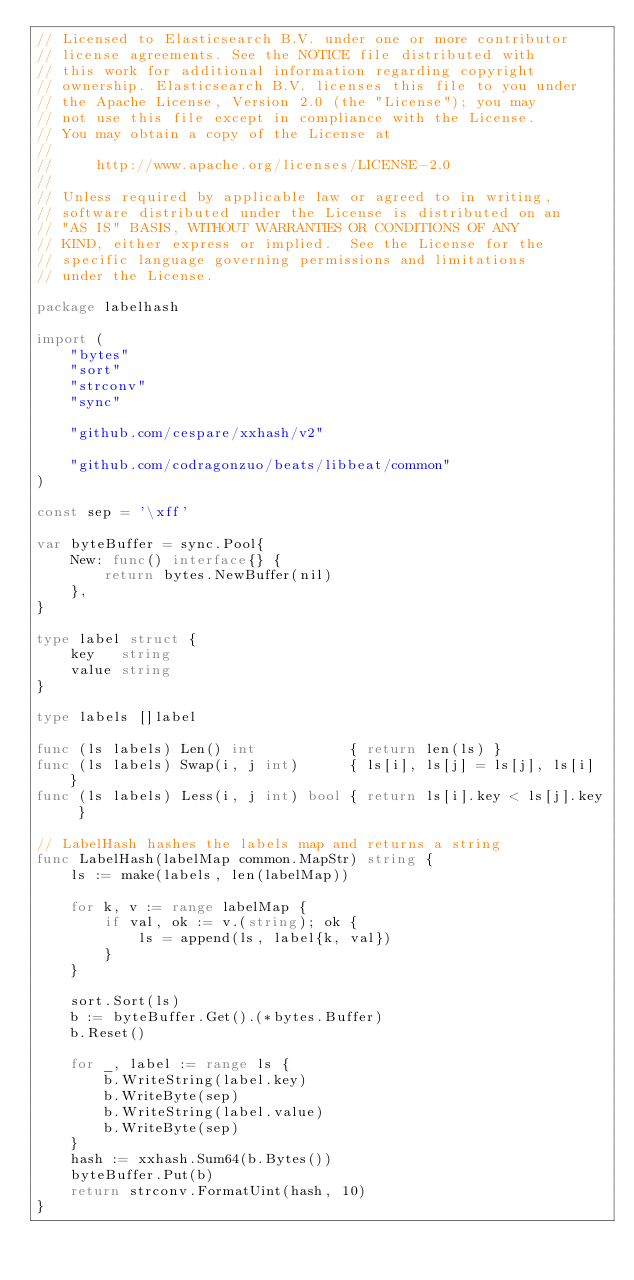<code> <loc_0><loc_0><loc_500><loc_500><_Go_>// Licensed to Elasticsearch B.V. under one or more contributor
// license agreements. See the NOTICE file distributed with
// this work for additional information regarding copyright
// ownership. Elasticsearch B.V. licenses this file to you under
// the Apache License, Version 2.0 (the "License"); you may
// not use this file except in compliance with the License.
// You may obtain a copy of the License at
//
//     http://www.apache.org/licenses/LICENSE-2.0
//
// Unless required by applicable law or agreed to in writing,
// software distributed under the License is distributed on an
// "AS IS" BASIS, WITHOUT WARRANTIES OR CONDITIONS OF ANY
// KIND, either express or implied.  See the License for the
// specific language governing permissions and limitations
// under the License.

package labelhash

import (
	"bytes"
	"sort"
	"strconv"
	"sync"

	"github.com/cespare/xxhash/v2"

	"github.com/codragonzuo/beats/libbeat/common"
)

const sep = '\xff'

var byteBuffer = sync.Pool{
	New: func() interface{} {
		return bytes.NewBuffer(nil)
	},
}

type label struct {
	key   string
	value string
}

type labels []label

func (ls labels) Len() int           { return len(ls) }
func (ls labels) Swap(i, j int)      { ls[i], ls[j] = ls[j], ls[i] }
func (ls labels) Less(i, j int) bool { return ls[i].key < ls[j].key }

// LabelHash hashes the labels map and returns a string
func LabelHash(labelMap common.MapStr) string {
	ls := make(labels, len(labelMap))

	for k, v := range labelMap {
		if val, ok := v.(string); ok {
			ls = append(ls, label{k, val})
		}
	}

	sort.Sort(ls)
	b := byteBuffer.Get().(*bytes.Buffer)
	b.Reset()

	for _, label := range ls {
		b.WriteString(label.key)
		b.WriteByte(sep)
		b.WriteString(label.value)
		b.WriteByte(sep)
	}
	hash := xxhash.Sum64(b.Bytes())
	byteBuffer.Put(b)
	return strconv.FormatUint(hash, 10)
}
</code> 